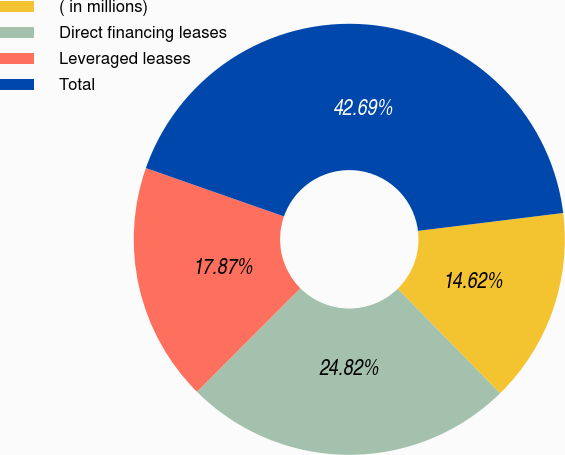Convert chart. <chart><loc_0><loc_0><loc_500><loc_500><pie_chart><fcel>( in millions)<fcel>Direct financing leases<fcel>Leveraged leases<fcel>Total<nl><fcel>14.62%<fcel>24.82%<fcel>17.87%<fcel>42.69%<nl></chart> 